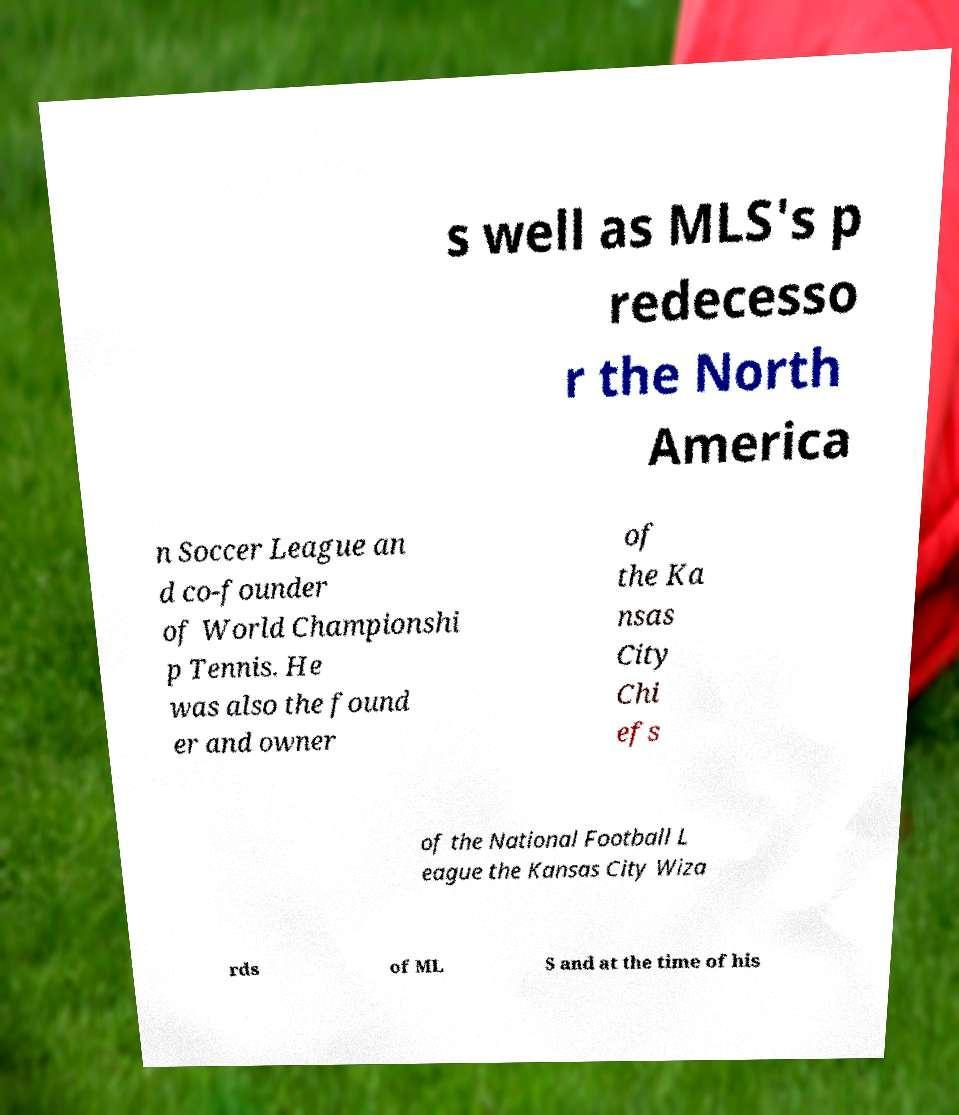What messages or text are displayed in this image? I need them in a readable, typed format. s well as MLS's p redecesso r the North America n Soccer League an d co-founder of World Championshi p Tennis. He was also the found er and owner of the Ka nsas City Chi efs of the National Football L eague the Kansas City Wiza rds of ML S and at the time of his 